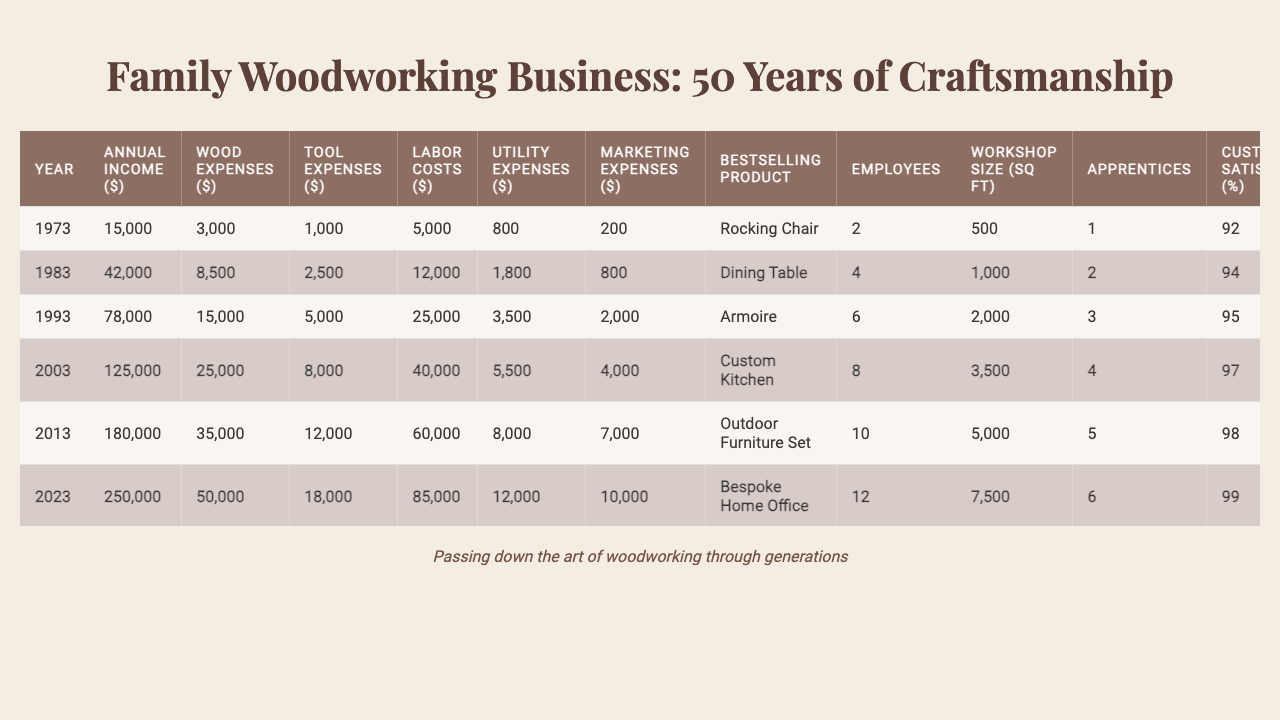What was the annual income in 2013? The annual income for the year 2013 is listed directly in the table, which shows it as 180,000 dollars.
Answer: 180,000 Which year had the highest wood expenses? Looking through the table for wood expenses, the maximum value is found for the year 2023, which is 50,000 dollars.
Answer: 2023 What is the percentage increase in annual income from 1973 to 2023? The annual income in 1973 was 15,000 dollars and in 2023 it was 250,000 dollars. The percentage increase is calculated as ((250,000 - 15,000) / 15,000) * 100 = 1566.67%.
Answer: 1566.67% What was the bestselling product in 2003? The table specifies that the bestselling product for the year 2003 was the "Custom Kitchen."
Answer: Custom Kitchen How many awards did the business receive in total from 1973 to 2023? The awards received over the years can be summed from the table: 0 + 1 + 2 + 4 + 6 + 9 = 22 awards total.
Answer: 22 What was the average labor cost from 2003 to 2023? The labor costs for 2003 to 2023 were 40,000, 60,000, and 85,000. The average is (40,000 + 60,000 + 85,000) / 3 = 61,666.67.
Answer: 61,666.67 Did the number of apprentices increase every decade? By examining the number of apprentices over the decades: 1, 2, 3, 4, 5, and 6 respectively, it's clear that the number increased each decade.
Answer: Yes In which year did the customer satisfaction rate reach 98%? The table shows that the customer satisfaction rate reached 98% in 2013.
Answer: 2013 What was the total expense in 2023? Total expenses for 2023 can be calculated by summing wood expenses (50,000), tool expenses (18,000), labor costs (85,000), utility expenses (12,000), and marketing expenses (10,000). The sum is 50,000 + 18,000 + 85,000 + 12,000 + 10,000 = 175,000 dollars.
Answer: 175,000 How many different types of wood were used in 1993? The table indicates that in 1993, the business used 8 different types of wood.
Answer: 8 